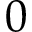<formula> <loc_0><loc_0><loc_500><loc_500>0</formula> 